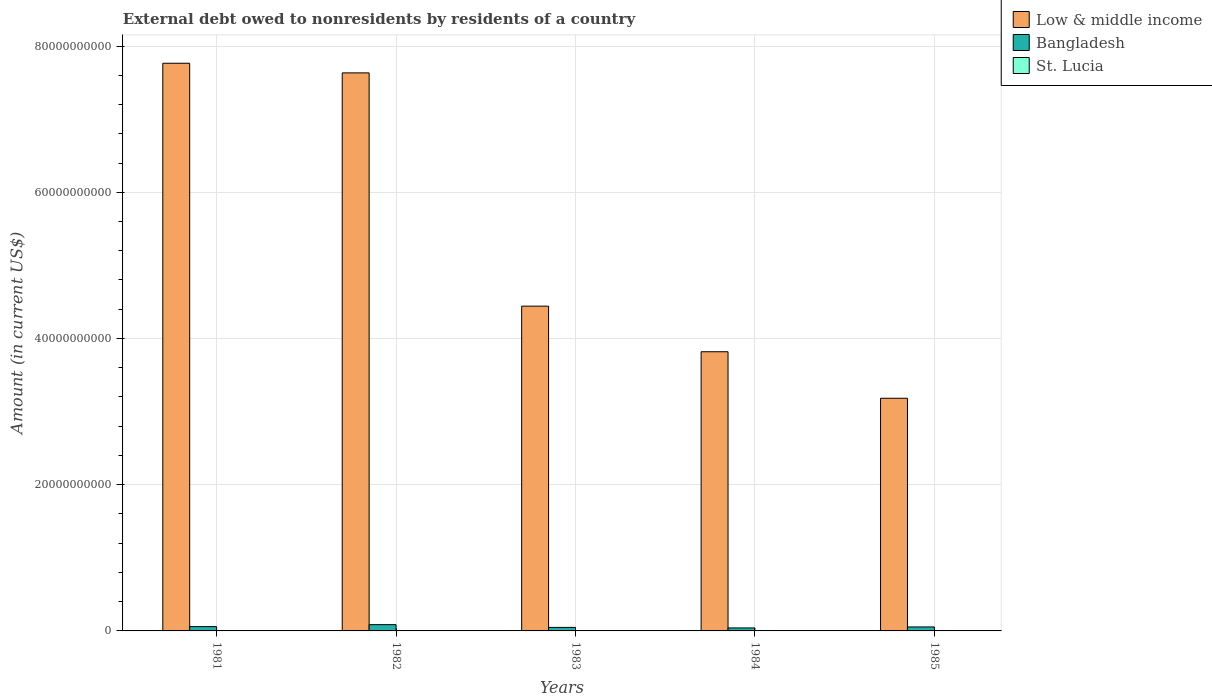How many different coloured bars are there?
Your response must be concise. 3. Are the number of bars on each tick of the X-axis equal?
Provide a short and direct response. Yes. How many bars are there on the 1st tick from the right?
Provide a short and direct response. 3. What is the label of the 4th group of bars from the left?
Provide a succinct answer. 1984. What is the external debt owed by residents in Low & middle income in 1981?
Ensure brevity in your answer.  7.76e+1. Across all years, what is the maximum external debt owed by residents in Bangladesh?
Ensure brevity in your answer.  8.58e+08. Across all years, what is the minimum external debt owed by residents in Low & middle income?
Your answer should be very brief. 3.18e+1. In which year was the external debt owed by residents in St. Lucia maximum?
Offer a terse response. 1984. In which year was the external debt owed by residents in Bangladesh minimum?
Provide a succinct answer. 1984. What is the total external debt owed by residents in Low & middle income in the graph?
Your response must be concise. 2.68e+11. What is the difference between the external debt owed by residents in St. Lucia in 1981 and that in 1983?
Offer a very short reply. -2.08e+05. What is the difference between the external debt owed by residents in Low & middle income in 1982 and the external debt owed by residents in Bangladesh in 1984?
Offer a very short reply. 7.59e+1. What is the average external debt owed by residents in Low & middle income per year?
Your answer should be very brief. 5.37e+1. In the year 1983, what is the difference between the external debt owed by residents in Low & middle income and external debt owed by residents in Bangladesh?
Ensure brevity in your answer.  4.39e+1. In how many years, is the external debt owed by residents in Low & middle income greater than 40000000000 US$?
Keep it short and to the point. 3. What is the ratio of the external debt owed by residents in Low & middle income in 1981 to that in 1982?
Your answer should be compact. 1.02. Is the external debt owed by residents in Low & middle income in 1981 less than that in 1982?
Give a very brief answer. No. Is the difference between the external debt owed by residents in Low & middle income in 1981 and 1982 greater than the difference between the external debt owed by residents in Bangladesh in 1981 and 1982?
Offer a terse response. Yes. What is the difference between the highest and the second highest external debt owed by residents in Low & middle income?
Offer a very short reply. 1.32e+09. What is the difference between the highest and the lowest external debt owed by residents in Low & middle income?
Offer a very short reply. 4.58e+1. What does the 3rd bar from the left in 1981 represents?
Offer a very short reply. St. Lucia. How many bars are there?
Provide a succinct answer. 15. Are all the bars in the graph horizontal?
Keep it short and to the point. No. What is the difference between two consecutive major ticks on the Y-axis?
Provide a succinct answer. 2.00e+1. Does the graph contain grids?
Offer a terse response. Yes. How many legend labels are there?
Keep it short and to the point. 3. What is the title of the graph?
Offer a terse response. External debt owed to nonresidents by residents of a country. Does "Hungary" appear as one of the legend labels in the graph?
Offer a very short reply. No. What is the label or title of the X-axis?
Your response must be concise. Years. What is the label or title of the Y-axis?
Your answer should be compact. Amount (in current US$). What is the Amount (in current US$) in Low & middle income in 1981?
Offer a terse response. 7.76e+1. What is the Amount (in current US$) in Bangladesh in 1981?
Give a very brief answer. 5.90e+08. What is the Amount (in current US$) in St. Lucia in 1981?
Your answer should be compact. 1.84e+06. What is the Amount (in current US$) of Low & middle income in 1982?
Keep it short and to the point. 7.63e+1. What is the Amount (in current US$) in Bangladesh in 1982?
Your answer should be compact. 8.58e+08. What is the Amount (in current US$) of St. Lucia in 1982?
Keep it short and to the point. 1.90e+06. What is the Amount (in current US$) in Low & middle income in 1983?
Ensure brevity in your answer.  4.44e+1. What is the Amount (in current US$) in Bangladesh in 1983?
Your response must be concise. 4.81e+08. What is the Amount (in current US$) of St. Lucia in 1983?
Make the answer very short. 2.05e+06. What is the Amount (in current US$) of Low & middle income in 1984?
Offer a very short reply. 3.82e+1. What is the Amount (in current US$) in Bangladesh in 1984?
Ensure brevity in your answer.  4.10e+08. What is the Amount (in current US$) in St. Lucia in 1984?
Offer a terse response. 3.34e+06. What is the Amount (in current US$) in Low & middle income in 1985?
Your answer should be compact. 3.18e+1. What is the Amount (in current US$) of Bangladesh in 1985?
Offer a very short reply. 5.45e+08. What is the Amount (in current US$) of St. Lucia in 1985?
Provide a short and direct response. 3.25e+06. Across all years, what is the maximum Amount (in current US$) in Low & middle income?
Give a very brief answer. 7.76e+1. Across all years, what is the maximum Amount (in current US$) of Bangladesh?
Keep it short and to the point. 8.58e+08. Across all years, what is the maximum Amount (in current US$) in St. Lucia?
Offer a very short reply. 3.34e+06. Across all years, what is the minimum Amount (in current US$) of Low & middle income?
Your response must be concise. 3.18e+1. Across all years, what is the minimum Amount (in current US$) in Bangladesh?
Provide a succinct answer. 4.10e+08. Across all years, what is the minimum Amount (in current US$) of St. Lucia?
Make the answer very short. 1.84e+06. What is the total Amount (in current US$) of Low & middle income in the graph?
Make the answer very short. 2.68e+11. What is the total Amount (in current US$) of Bangladesh in the graph?
Ensure brevity in your answer.  2.88e+09. What is the total Amount (in current US$) in St. Lucia in the graph?
Give a very brief answer. 1.24e+07. What is the difference between the Amount (in current US$) of Low & middle income in 1981 and that in 1982?
Provide a short and direct response. 1.32e+09. What is the difference between the Amount (in current US$) of Bangladesh in 1981 and that in 1982?
Provide a short and direct response. -2.68e+08. What is the difference between the Amount (in current US$) in St. Lucia in 1981 and that in 1982?
Ensure brevity in your answer.  -6.10e+04. What is the difference between the Amount (in current US$) in Low & middle income in 1981 and that in 1983?
Your answer should be compact. 3.32e+1. What is the difference between the Amount (in current US$) in Bangladesh in 1981 and that in 1983?
Make the answer very short. 1.09e+08. What is the difference between the Amount (in current US$) in St. Lucia in 1981 and that in 1983?
Offer a very short reply. -2.08e+05. What is the difference between the Amount (in current US$) in Low & middle income in 1981 and that in 1984?
Your answer should be very brief. 3.95e+1. What is the difference between the Amount (in current US$) in Bangladesh in 1981 and that in 1984?
Ensure brevity in your answer.  1.80e+08. What is the difference between the Amount (in current US$) in St. Lucia in 1981 and that in 1984?
Your answer should be very brief. -1.50e+06. What is the difference between the Amount (in current US$) of Low & middle income in 1981 and that in 1985?
Give a very brief answer. 4.58e+1. What is the difference between the Amount (in current US$) in Bangladesh in 1981 and that in 1985?
Give a very brief answer. 4.54e+07. What is the difference between the Amount (in current US$) in St. Lucia in 1981 and that in 1985?
Provide a succinct answer. -1.40e+06. What is the difference between the Amount (in current US$) of Low & middle income in 1982 and that in 1983?
Ensure brevity in your answer.  3.19e+1. What is the difference between the Amount (in current US$) in Bangladesh in 1982 and that in 1983?
Your response must be concise. 3.77e+08. What is the difference between the Amount (in current US$) of St. Lucia in 1982 and that in 1983?
Your answer should be very brief. -1.47e+05. What is the difference between the Amount (in current US$) in Low & middle income in 1982 and that in 1984?
Give a very brief answer. 3.81e+1. What is the difference between the Amount (in current US$) of Bangladesh in 1982 and that in 1984?
Give a very brief answer. 4.49e+08. What is the difference between the Amount (in current US$) of St. Lucia in 1982 and that in 1984?
Provide a short and direct response. -1.44e+06. What is the difference between the Amount (in current US$) in Low & middle income in 1982 and that in 1985?
Your answer should be compact. 4.45e+1. What is the difference between the Amount (in current US$) in Bangladesh in 1982 and that in 1985?
Provide a short and direct response. 3.14e+08. What is the difference between the Amount (in current US$) of St. Lucia in 1982 and that in 1985?
Your response must be concise. -1.34e+06. What is the difference between the Amount (in current US$) in Low & middle income in 1983 and that in 1984?
Your response must be concise. 6.24e+09. What is the difference between the Amount (in current US$) in Bangladesh in 1983 and that in 1984?
Ensure brevity in your answer.  7.13e+07. What is the difference between the Amount (in current US$) in St. Lucia in 1983 and that in 1984?
Keep it short and to the point. -1.30e+06. What is the difference between the Amount (in current US$) of Low & middle income in 1983 and that in 1985?
Your answer should be very brief. 1.26e+1. What is the difference between the Amount (in current US$) of Bangladesh in 1983 and that in 1985?
Make the answer very short. -6.36e+07. What is the difference between the Amount (in current US$) of St. Lucia in 1983 and that in 1985?
Offer a terse response. -1.20e+06. What is the difference between the Amount (in current US$) in Low & middle income in 1984 and that in 1985?
Your response must be concise. 6.36e+09. What is the difference between the Amount (in current US$) of Bangladesh in 1984 and that in 1985?
Provide a succinct answer. -1.35e+08. What is the difference between the Amount (in current US$) in St. Lucia in 1984 and that in 1985?
Keep it short and to the point. 9.90e+04. What is the difference between the Amount (in current US$) in Low & middle income in 1981 and the Amount (in current US$) in Bangladesh in 1982?
Your response must be concise. 7.68e+1. What is the difference between the Amount (in current US$) of Low & middle income in 1981 and the Amount (in current US$) of St. Lucia in 1982?
Ensure brevity in your answer.  7.76e+1. What is the difference between the Amount (in current US$) in Bangladesh in 1981 and the Amount (in current US$) in St. Lucia in 1982?
Give a very brief answer. 5.88e+08. What is the difference between the Amount (in current US$) of Low & middle income in 1981 and the Amount (in current US$) of Bangladesh in 1983?
Offer a very short reply. 7.72e+1. What is the difference between the Amount (in current US$) of Low & middle income in 1981 and the Amount (in current US$) of St. Lucia in 1983?
Keep it short and to the point. 7.76e+1. What is the difference between the Amount (in current US$) of Bangladesh in 1981 and the Amount (in current US$) of St. Lucia in 1983?
Your response must be concise. 5.88e+08. What is the difference between the Amount (in current US$) in Low & middle income in 1981 and the Amount (in current US$) in Bangladesh in 1984?
Make the answer very short. 7.72e+1. What is the difference between the Amount (in current US$) in Low & middle income in 1981 and the Amount (in current US$) in St. Lucia in 1984?
Offer a very short reply. 7.76e+1. What is the difference between the Amount (in current US$) of Bangladesh in 1981 and the Amount (in current US$) of St. Lucia in 1984?
Provide a short and direct response. 5.87e+08. What is the difference between the Amount (in current US$) of Low & middle income in 1981 and the Amount (in current US$) of Bangladesh in 1985?
Your response must be concise. 7.71e+1. What is the difference between the Amount (in current US$) of Low & middle income in 1981 and the Amount (in current US$) of St. Lucia in 1985?
Provide a succinct answer. 7.76e+1. What is the difference between the Amount (in current US$) of Bangladesh in 1981 and the Amount (in current US$) of St. Lucia in 1985?
Give a very brief answer. 5.87e+08. What is the difference between the Amount (in current US$) of Low & middle income in 1982 and the Amount (in current US$) of Bangladesh in 1983?
Make the answer very short. 7.58e+1. What is the difference between the Amount (in current US$) of Low & middle income in 1982 and the Amount (in current US$) of St. Lucia in 1983?
Give a very brief answer. 7.63e+1. What is the difference between the Amount (in current US$) of Bangladesh in 1982 and the Amount (in current US$) of St. Lucia in 1983?
Your answer should be very brief. 8.56e+08. What is the difference between the Amount (in current US$) of Low & middle income in 1982 and the Amount (in current US$) of Bangladesh in 1984?
Provide a succinct answer. 7.59e+1. What is the difference between the Amount (in current US$) in Low & middle income in 1982 and the Amount (in current US$) in St. Lucia in 1984?
Your answer should be very brief. 7.63e+1. What is the difference between the Amount (in current US$) of Bangladesh in 1982 and the Amount (in current US$) of St. Lucia in 1984?
Keep it short and to the point. 8.55e+08. What is the difference between the Amount (in current US$) of Low & middle income in 1982 and the Amount (in current US$) of Bangladesh in 1985?
Keep it short and to the point. 7.58e+1. What is the difference between the Amount (in current US$) in Low & middle income in 1982 and the Amount (in current US$) in St. Lucia in 1985?
Ensure brevity in your answer.  7.63e+1. What is the difference between the Amount (in current US$) in Bangladesh in 1982 and the Amount (in current US$) in St. Lucia in 1985?
Your response must be concise. 8.55e+08. What is the difference between the Amount (in current US$) in Low & middle income in 1983 and the Amount (in current US$) in Bangladesh in 1984?
Provide a short and direct response. 4.40e+1. What is the difference between the Amount (in current US$) of Low & middle income in 1983 and the Amount (in current US$) of St. Lucia in 1984?
Provide a short and direct response. 4.44e+1. What is the difference between the Amount (in current US$) in Bangladesh in 1983 and the Amount (in current US$) in St. Lucia in 1984?
Give a very brief answer. 4.78e+08. What is the difference between the Amount (in current US$) in Low & middle income in 1983 and the Amount (in current US$) in Bangladesh in 1985?
Make the answer very short. 4.39e+1. What is the difference between the Amount (in current US$) in Low & middle income in 1983 and the Amount (in current US$) in St. Lucia in 1985?
Offer a terse response. 4.44e+1. What is the difference between the Amount (in current US$) of Bangladesh in 1983 and the Amount (in current US$) of St. Lucia in 1985?
Your response must be concise. 4.78e+08. What is the difference between the Amount (in current US$) of Low & middle income in 1984 and the Amount (in current US$) of Bangladesh in 1985?
Give a very brief answer. 3.76e+1. What is the difference between the Amount (in current US$) in Low & middle income in 1984 and the Amount (in current US$) in St. Lucia in 1985?
Ensure brevity in your answer.  3.82e+1. What is the difference between the Amount (in current US$) in Bangladesh in 1984 and the Amount (in current US$) in St. Lucia in 1985?
Provide a short and direct response. 4.07e+08. What is the average Amount (in current US$) in Low & middle income per year?
Your answer should be compact. 5.37e+1. What is the average Amount (in current US$) in Bangladesh per year?
Offer a terse response. 5.77e+08. What is the average Amount (in current US$) of St. Lucia per year?
Give a very brief answer. 2.48e+06. In the year 1981, what is the difference between the Amount (in current US$) in Low & middle income and Amount (in current US$) in Bangladesh?
Offer a terse response. 7.71e+1. In the year 1981, what is the difference between the Amount (in current US$) in Low & middle income and Amount (in current US$) in St. Lucia?
Your response must be concise. 7.76e+1. In the year 1981, what is the difference between the Amount (in current US$) of Bangladesh and Amount (in current US$) of St. Lucia?
Your response must be concise. 5.88e+08. In the year 1982, what is the difference between the Amount (in current US$) in Low & middle income and Amount (in current US$) in Bangladesh?
Ensure brevity in your answer.  7.55e+1. In the year 1982, what is the difference between the Amount (in current US$) in Low & middle income and Amount (in current US$) in St. Lucia?
Provide a succinct answer. 7.63e+1. In the year 1982, what is the difference between the Amount (in current US$) of Bangladesh and Amount (in current US$) of St. Lucia?
Provide a short and direct response. 8.57e+08. In the year 1983, what is the difference between the Amount (in current US$) in Low & middle income and Amount (in current US$) in Bangladesh?
Ensure brevity in your answer.  4.39e+1. In the year 1983, what is the difference between the Amount (in current US$) of Low & middle income and Amount (in current US$) of St. Lucia?
Provide a succinct answer. 4.44e+1. In the year 1983, what is the difference between the Amount (in current US$) of Bangladesh and Amount (in current US$) of St. Lucia?
Provide a succinct answer. 4.79e+08. In the year 1984, what is the difference between the Amount (in current US$) in Low & middle income and Amount (in current US$) in Bangladesh?
Provide a short and direct response. 3.78e+1. In the year 1984, what is the difference between the Amount (in current US$) of Low & middle income and Amount (in current US$) of St. Lucia?
Keep it short and to the point. 3.82e+1. In the year 1984, what is the difference between the Amount (in current US$) of Bangladesh and Amount (in current US$) of St. Lucia?
Your answer should be very brief. 4.06e+08. In the year 1985, what is the difference between the Amount (in current US$) in Low & middle income and Amount (in current US$) in Bangladesh?
Give a very brief answer. 3.13e+1. In the year 1985, what is the difference between the Amount (in current US$) in Low & middle income and Amount (in current US$) in St. Lucia?
Provide a short and direct response. 3.18e+1. In the year 1985, what is the difference between the Amount (in current US$) of Bangladesh and Amount (in current US$) of St. Lucia?
Your answer should be compact. 5.42e+08. What is the ratio of the Amount (in current US$) in Low & middle income in 1981 to that in 1982?
Make the answer very short. 1.02. What is the ratio of the Amount (in current US$) in Bangladesh in 1981 to that in 1982?
Keep it short and to the point. 0.69. What is the ratio of the Amount (in current US$) of St. Lucia in 1981 to that in 1982?
Provide a short and direct response. 0.97. What is the ratio of the Amount (in current US$) of Low & middle income in 1981 to that in 1983?
Your response must be concise. 1.75. What is the ratio of the Amount (in current US$) of Bangladesh in 1981 to that in 1983?
Give a very brief answer. 1.23. What is the ratio of the Amount (in current US$) in St. Lucia in 1981 to that in 1983?
Provide a short and direct response. 0.9. What is the ratio of the Amount (in current US$) of Low & middle income in 1981 to that in 1984?
Give a very brief answer. 2.03. What is the ratio of the Amount (in current US$) in Bangladesh in 1981 to that in 1984?
Provide a short and direct response. 1.44. What is the ratio of the Amount (in current US$) in St. Lucia in 1981 to that in 1984?
Your response must be concise. 0.55. What is the ratio of the Amount (in current US$) in Low & middle income in 1981 to that in 1985?
Provide a short and direct response. 2.44. What is the ratio of the Amount (in current US$) in Bangladesh in 1981 to that in 1985?
Give a very brief answer. 1.08. What is the ratio of the Amount (in current US$) in St. Lucia in 1981 to that in 1985?
Make the answer very short. 0.57. What is the ratio of the Amount (in current US$) in Low & middle income in 1982 to that in 1983?
Your answer should be compact. 1.72. What is the ratio of the Amount (in current US$) of Bangladesh in 1982 to that in 1983?
Keep it short and to the point. 1.78. What is the ratio of the Amount (in current US$) in St. Lucia in 1982 to that in 1983?
Keep it short and to the point. 0.93. What is the ratio of the Amount (in current US$) of Low & middle income in 1982 to that in 1984?
Give a very brief answer. 2. What is the ratio of the Amount (in current US$) of Bangladesh in 1982 to that in 1984?
Offer a terse response. 2.09. What is the ratio of the Amount (in current US$) in St. Lucia in 1982 to that in 1984?
Your answer should be compact. 0.57. What is the ratio of the Amount (in current US$) of Low & middle income in 1982 to that in 1985?
Provide a succinct answer. 2.4. What is the ratio of the Amount (in current US$) of Bangladesh in 1982 to that in 1985?
Make the answer very short. 1.58. What is the ratio of the Amount (in current US$) in St. Lucia in 1982 to that in 1985?
Give a very brief answer. 0.59. What is the ratio of the Amount (in current US$) in Low & middle income in 1983 to that in 1984?
Offer a terse response. 1.16. What is the ratio of the Amount (in current US$) of Bangladesh in 1983 to that in 1984?
Make the answer very short. 1.17. What is the ratio of the Amount (in current US$) in St. Lucia in 1983 to that in 1984?
Offer a very short reply. 0.61. What is the ratio of the Amount (in current US$) of Low & middle income in 1983 to that in 1985?
Provide a succinct answer. 1.4. What is the ratio of the Amount (in current US$) of Bangladesh in 1983 to that in 1985?
Ensure brevity in your answer.  0.88. What is the ratio of the Amount (in current US$) in St. Lucia in 1983 to that in 1985?
Your answer should be very brief. 0.63. What is the ratio of the Amount (in current US$) of Low & middle income in 1984 to that in 1985?
Provide a succinct answer. 1.2. What is the ratio of the Amount (in current US$) of Bangladesh in 1984 to that in 1985?
Your answer should be compact. 0.75. What is the ratio of the Amount (in current US$) of St. Lucia in 1984 to that in 1985?
Offer a very short reply. 1.03. What is the difference between the highest and the second highest Amount (in current US$) in Low & middle income?
Your response must be concise. 1.32e+09. What is the difference between the highest and the second highest Amount (in current US$) of Bangladesh?
Make the answer very short. 2.68e+08. What is the difference between the highest and the second highest Amount (in current US$) in St. Lucia?
Make the answer very short. 9.90e+04. What is the difference between the highest and the lowest Amount (in current US$) of Low & middle income?
Your answer should be compact. 4.58e+1. What is the difference between the highest and the lowest Amount (in current US$) in Bangladesh?
Your response must be concise. 4.49e+08. What is the difference between the highest and the lowest Amount (in current US$) of St. Lucia?
Ensure brevity in your answer.  1.50e+06. 